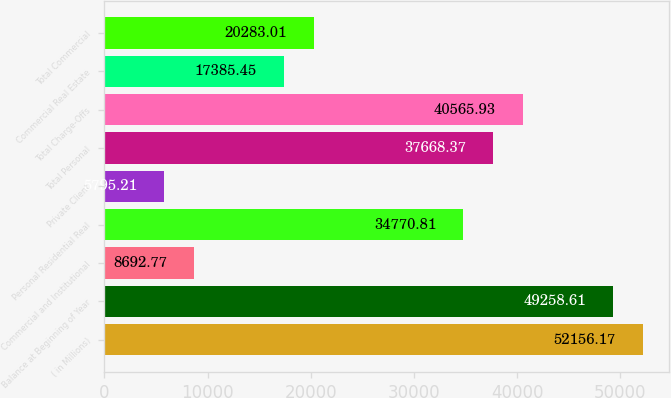Convert chart. <chart><loc_0><loc_0><loc_500><loc_500><bar_chart><fcel>( in Millions)<fcel>Balance at Beginning of Year<fcel>Commercial and Institutional<fcel>Personal Residential Real<fcel>Private Client<fcel>Total Personal<fcel>Total Charge-Offs<fcel>Commercial Real Estate<fcel>Total Commercial<nl><fcel>52156.2<fcel>49258.6<fcel>8692.77<fcel>34770.8<fcel>5795.21<fcel>37668.4<fcel>40565.9<fcel>17385.5<fcel>20283<nl></chart> 